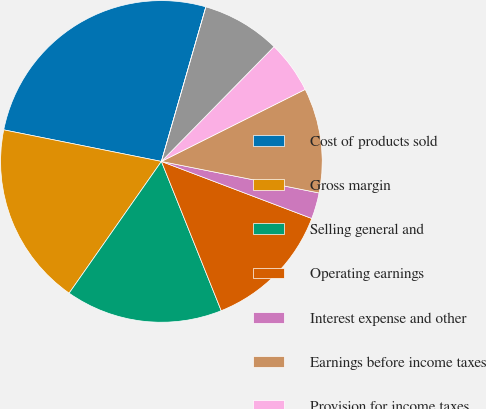Convert chart. <chart><loc_0><loc_0><loc_500><loc_500><pie_chart><fcel>Cost of products sold<fcel>Gross margin<fcel>Selling general and<fcel>Operating earnings<fcel>Interest expense and other<fcel>Earnings before income taxes<fcel>Provision for income taxes<fcel>Earnings from continuing<fcel>Net diluted earnings per<nl><fcel>26.31%<fcel>18.42%<fcel>15.79%<fcel>13.16%<fcel>2.63%<fcel>10.53%<fcel>5.26%<fcel>7.89%<fcel>0.0%<nl></chart> 